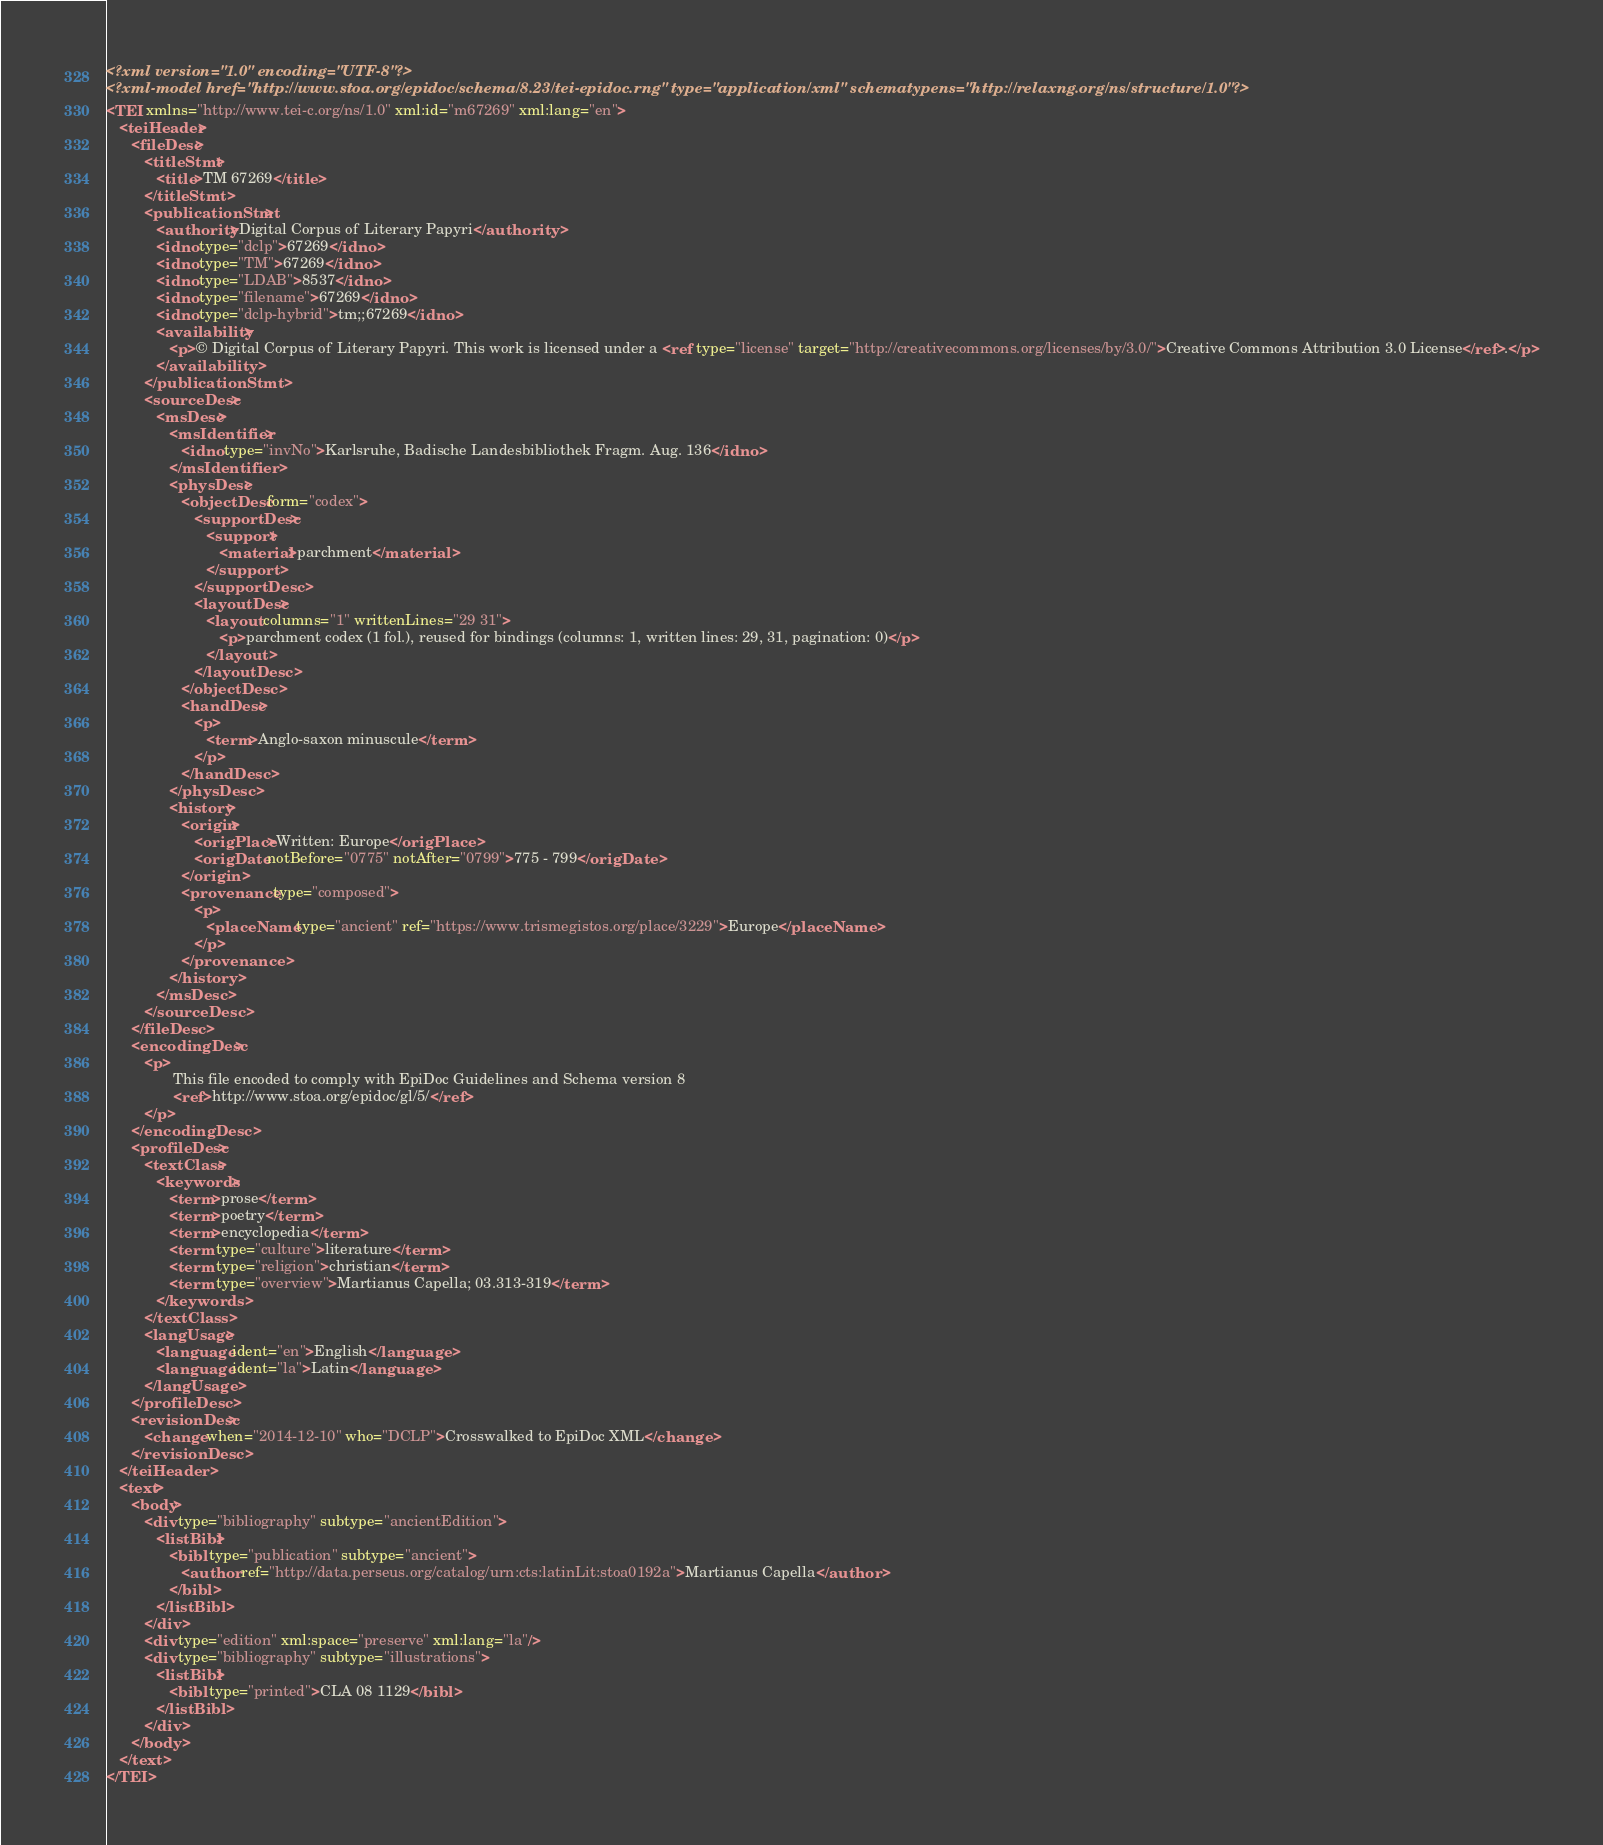<code> <loc_0><loc_0><loc_500><loc_500><_XML_><?xml version="1.0" encoding="UTF-8"?>
<?xml-model href="http://www.stoa.org/epidoc/schema/8.23/tei-epidoc.rng" type="application/xml" schematypens="http://relaxng.org/ns/structure/1.0"?>
<TEI xmlns="http://www.tei-c.org/ns/1.0" xml:id="m67269" xml:lang="en">
   <teiHeader>
      <fileDesc>
         <titleStmt>
            <title>TM 67269</title>
         </titleStmt>
         <publicationStmt>
            <authority>Digital Corpus of Literary Papyri</authority>
            <idno type="dclp">67269</idno>
            <idno type="TM">67269</idno>
            <idno type="LDAB">8537</idno>
            <idno type="filename">67269</idno>
            <idno type="dclp-hybrid">tm;;67269</idno>
            <availability>
               <p>© Digital Corpus of Literary Papyri. This work is licensed under a <ref type="license" target="http://creativecommons.org/licenses/by/3.0/">Creative Commons Attribution 3.0 License</ref>.</p>
            </availability>
         </publicationStmt>
         <sourceDesc>
            <msDesc>
               <msIdentifier>
                  <idno type="invNo">Karlsruhe, Badische Landesbibliothek Fragm. Aug. 136</idno>
               </msIdentifier>
               <physDesc>
                  <objectDesc form="codex">
                     <supportDesc>
                        <support>
                           <material>parchment</material>
                        </support>
                     </supportDesc>
                     <layoutDesc>
                        <layout columns="1" writtenLines="29 31">
                           <p>parchment codex (1 fol.), reused for bindings (columns: 1, written lines: 29, 31, pagination: 0)</p>
                        </layout>
                     </layoutDesc>
                  </objectDesc>
                  <handDesc>
                     <p>
                        <term>Anglo-saxon minuscule</term>
                     </p>
                  </handDesc>
               </physDesc>
               <history>
                  <origin>
                     <origPlace>Written: Europe</origPlace>
                     <origDate notBefore="0775" notAfter="0799">775 - 799</origDate>
                  </origin>
                  <provenance type="composed">
                     <p>
                        <placeName type="ancient" ref="https://www.trismegistos.org/place/3229">Europe</placeName>
                     </p>
                  </provenance>
               </history>
            </msDesc>
         </sourceDesc>
      </fileDesc>
      <encodingDesc>
         <p>
                This file encoded to comply with EpiDoc Guidelines and Schema version 8
                <ref>http://www.stoa.org/epidoc/gl/5/</ref>
         </p>
      </encodingDesc>
      <profileDesc>
         <textClass>
            <keywords>
               <term>prose</term>
               <term>poetry</term>
               <term>encyclopedia</term>
               <term type="culture">literature</term>
               <term type="religion">christian</term>
               <term type="overview">Martianus Capella; 03.313-319</term>
            </keywords>
         </textClass>
         <langUsage>
            <language ident="en">English</language>
            <language ident="la">Latin</language>
         </langUsage>
      </profileDesc>
      <revisionDesc>
         <change when="2014-12-10" who="DCLP">Crosswalked to EpiDoc XML</change>
      </revisionDesc>
   </teiHeader>
   <text>
      <body>
         <div type="bibliography" subtype="ancientEdition">
            <listBibl>
               <bibl type="publication" subtype="ancient">
                  <author ref="http://data.perseus.org/catalog/urn:cts:latinLit:stoa0192a">Martianus Capella</author>
               </bibl>
            </listBibl>
         </div>
         <div type="edition" xml:space="preserve" xml:lang="la"/>
         <div type="bibliography" subtype="illustrations">
            <listBibl>
               <bibl type="printed">CLA 08 1129</bibl>
            </listBibl>
         </div>
      </body>
   </text>
</TEI>
</code> 